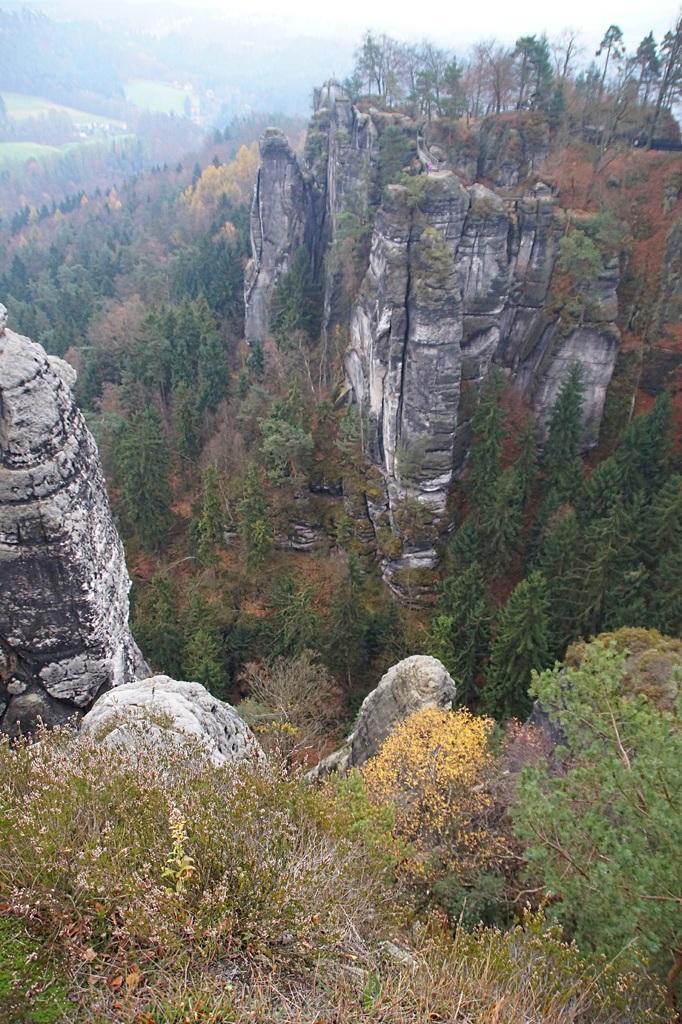Could you give a brief overview of what you see in this image? In this image I can see few mountains, few plants which are green and yellow in color. In the background I can see few mountains, few trees and the sky. 